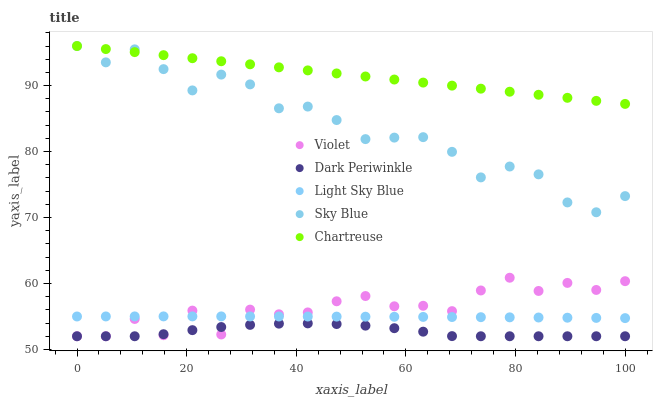Does Dark Periwinkle have the minimum area under the curve?
Answer yes or no. Yes. Does Chartreuse have the maximum area under the curve?
Answer yes or no. Yes. Does Light Sky Blue have the minimum area under the curve?
Answer yes or no. No. Does Light Sky Blue have the maximum area under the curve?
Answer yes or no. No. Is Chartreuse the smoothest?
Answer yes or no. Yes. Is Violet the roughest?
Answer yes or no. Yes. Is Light Sky Blue the smoothest?
Answer yes or no. No. Is Light Sky Blue the roughest?
Answer yes or no. No. Does Dark Periwinkle have the lowest value?
Answer yes or no. Yes. Does Light Sky Blue have the lowest value?
Answer yes or no. No. Does Chartreuse have the highest value?
Answer yes or no. Yes. Does Light Sky Blue have the highest value?
Answer yes or no. No. Is Dark Periwinkle less than Chartreuse?
Answer yes or no. Yes. Is Chartreuse greater than Violet?
Answer yes or no. Yes. Does Violet intersect Dark Periwinkle?
Answer yes or no. Yes. Is Violet less than Dark Periwinkle?
Answer yes or no. No. Is Violet greater than Dark Periwinkle?
Answer yes or no. No. Does Dark Periwinkle intersect Chartreuse?
Answer yes or no. No. 